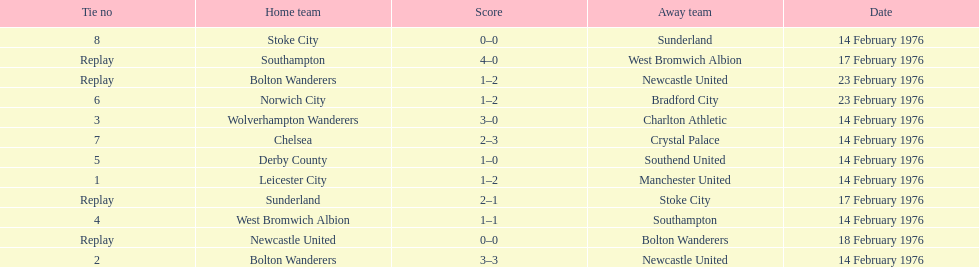How many games were replays? 4. 